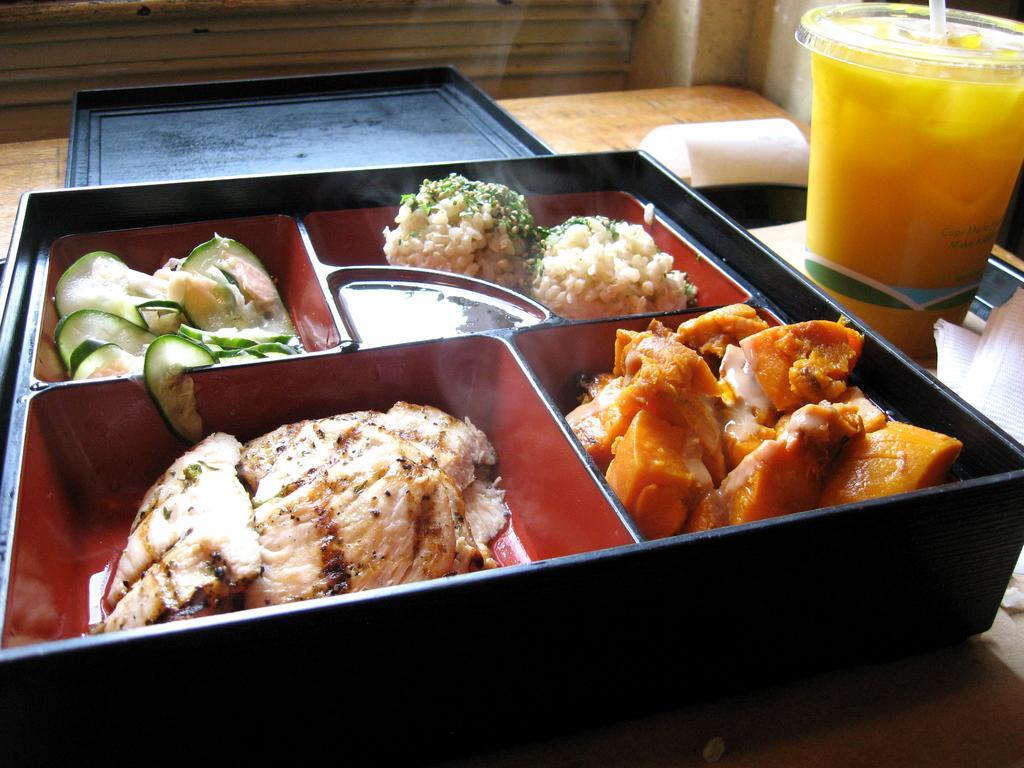Please provide a concise description of this image. This image is taken indoors. In the background there is a wall. At the bottom of the image there is a table with a few things on it. On the right side of the image there is a tumbler with juice and a straw on the table. There are a few tissue papers and there is a tray on the table. In the middle of the image there is a box with a few food items and the box is placed on the table. 